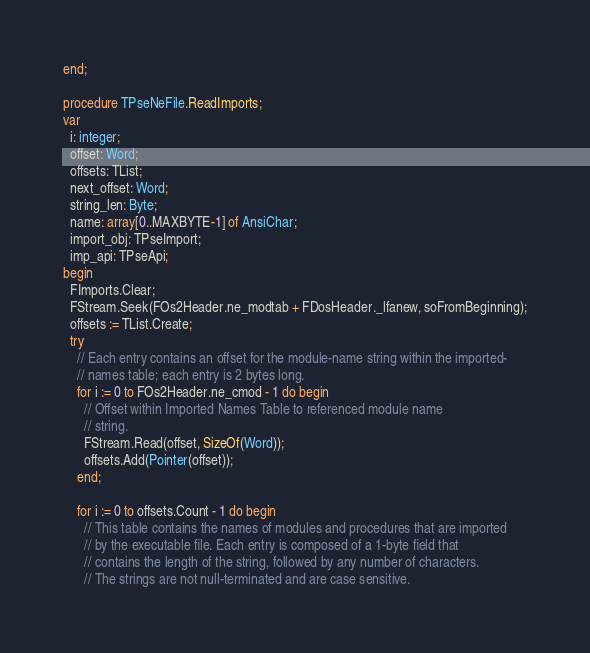Convert code to text. <code><loc_0><loc_0><loc_500><loc_500><_Pascal_>end;

procedure TPseNeFile.ReadImports;
var
  i: integer;
  offset: Word;
  offsets: TList;
  next_offset: Word;
  string_len: Byte;
  name: array[0..MAXBYTE-1] of AnsiChar;
  import_obj: TPseImport;
  imp_api: TPseApi;
begin
  FImports.Clear;
  FStream.Seek(FOs2Header.ne_modtab + FDosHeader._lfanew, soFromBeginning);
  offsets := TList.Create;
  try
    // Each entry contains an offset for the module-name string within the imported-
    // names table; each entry is 2 bytes long.
    for i := 0 to FOs2Header.ne_cmod - 1 do begin
      // Offset within Imported Names Table to referenced module name
      // string.
      FStream.Read(offset, SizeOf(Word));
      offsets.Add(Pointer(offset));
    end;

    for i := 0 to offsets.Count - 1 do begin
      // This table contains the names of modules and procedures that are imported
      // by the executable file. Each entry is composed of a 1-byte field that
      // contains the length of the string, followed by any number of characters.
      // The strings are not null-terminated and are case sensitive.</code> 